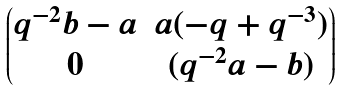Convert formula to latex. <formula><loc_0><loc_0><loc_500><loc_500>\begin{pmatrix} q ^ { - 2 } b - a & a ( - q + q ^ { - 3 } ) \\ 0 & ( q ^ { - 2 } a - b ) \end{pmatrix}</formula> 